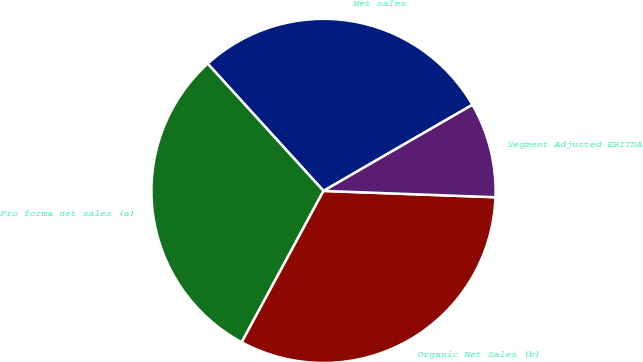<chart> <loc_0><loc_0><loc_500><loc_500><pie_chart><fcel>Net sales<fcel>Pro forma net sales (a)<fcel>Organic Net Sales (b)<fcel>Segment Adjusted EBITDA<nl><fcel>28.41%<fcel>30.36%<fcel>32.3%<fcel>8.93%<nl></chart> 